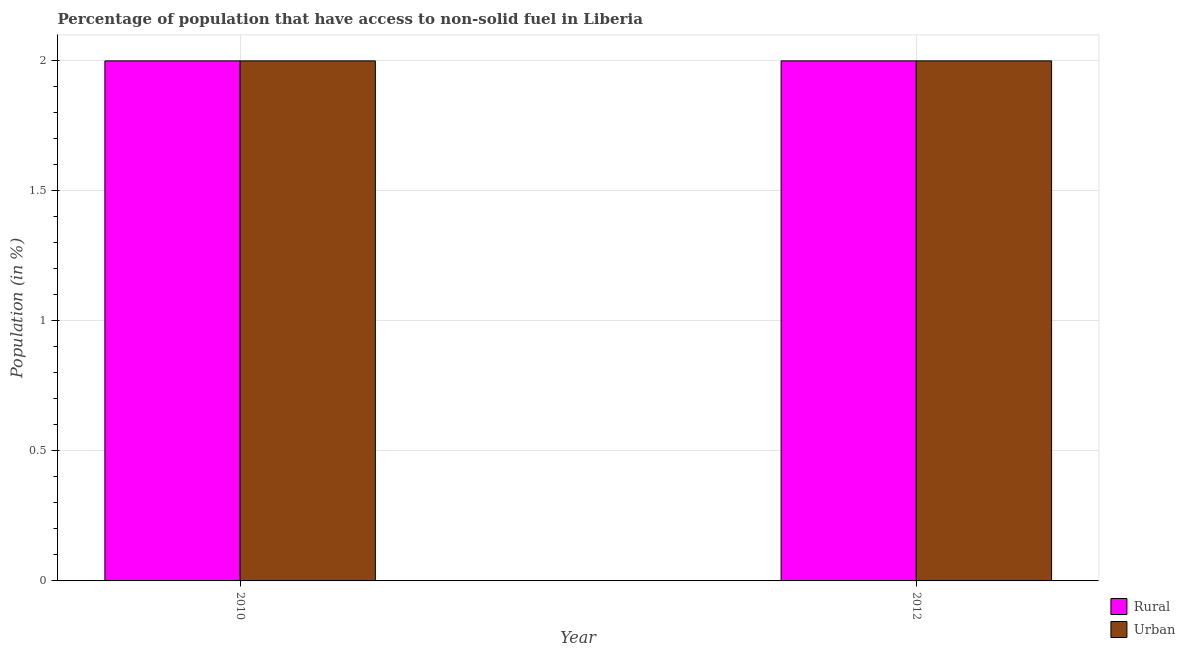How many different coloured bars are there?
Ensure brevity in your answer.  2. How many groups of bars are there?
Your answer should be very brief. 2. How many bars are there on the 1st tick from the left?
Provide a short and direct response. 2. In how many cases, is the number of bars for a given year not equal to the number of legend labels?
Your answer should be compact. 0. What is the rural population in 2010?
Ensure brevity in your answer.  2. Across all years, what is the maximum rural population?
Your answer should be very brief. 2. Across all years, what is the minimum rural population?
Make the answer very short. 2. In which year was the urban population maximum?
Provide a succinct answer. 2010. In which year was the urban population minimum?
Offer a terse response. 2010. What is the total rural population in the graph?
Offer a terse response. 4. What is the difference between the rural population in 2010 and that in 2012?
Give a very brief answer. 0. What is the difference between the urban population in 2012 and the rural population in 2010?
Offer a very short reply. 0. What is the average urban population per year?
Give a very brief answer. 2. In the year 2012, what is the difference between the rural population and urban population?
Your answer should be compact. 0. In how many years, is the urban population greater than the average urban population taken over all years?
Offer a very short reply. 0. What does the 2nd bar from the left in 2010 represents?
Your answer should be very brief. Urban. What does the 1st bar from the right in 2012 represents?
Keep it short and to the point. Urban. Are all the bars in the graph horizontal?
Give a very brief answer. No. How many years are there in the graph?
Provide a short and direct response. 2. What is the difference between two consecutive major ticks on the Y-axis?
Offer a terse response. 0.5. Are the values on the major ticks of Y-axis written in scientific E-notation?
Ensure brevity in your answer.  No. Does the graph contain any zero values?
Provide a short and direct response. No. How many legend labels are there?
Your answer should be compact. 2. What is the title of the graph?
Make the answer very short. Percentage of population that have access to non-solid fuel in Liberia. Does "Ages 15-24" appear as one of the legend labels in the graph?
Provide a short and direct response. No. What is the label or title of the Y-axis?
Provide a short and direct response. Population (in %). What is the Population (in %) of Rural in 2010?
Your answer should be compact. 2. What is the Population (in %) in Urban in 2010?
Make the answer very short. 2. What is the Population (in %) in Rural in 2012?
Your answer should be compact. 2. What is the Population (in %) of Urban in 2012?
Provide a short and direct response. 2. Across all years, what is the maximum Population (in %) in Rural?
Offer a very short reply. 2. Across all years, what is the maximum Population (in %) in Urban?
Your answer should be compact. 2. Across all years, what is the minimum Population (in %) in Rural?
Your answer should be compact. 2. Across all years, what is the minimum Population (in %) of Urban?
Provide a succinct answer. 2. What is the total Population (in %) in Rural in the graph?
Your response must be concise. 4. What is the total Population (in %) of Urban in the graph?
Your answer should be compact. 4. What is the difference between the Population (in %) of Urban in 2010 and that in 2012?
Your response must be concise. 0. What is the difference between the Population (in %) of Rural in 2010 and the Population (in %) of Urban in 2012?
Offer a very short reply. 0. What is the average Population (in %) in Rural per year?
Ensure brevity in your answer.  2. What is the average Population (in %) of Urban per year?
Your answer should be very brief. 2. In the year 2010, what is the difference between the Population (in %) in Rural and Population (in %) in Urban?
Offer a terse response. 0. What is the ratio of the Population (in %) of Rural in 2010 to that in 2012?
Ensure brevity in your answer.  1. What is the difference between the highest and the second highest Population (in %) in Rural?
Your answer should be compact. 0. What is the difference between the highest and the second highest Population (in %) of Urban?
Offer a terse response. 0. What is the difference between the highest and the lowest Population (in %) in Urban?
Your answer should be very brief. 0. 